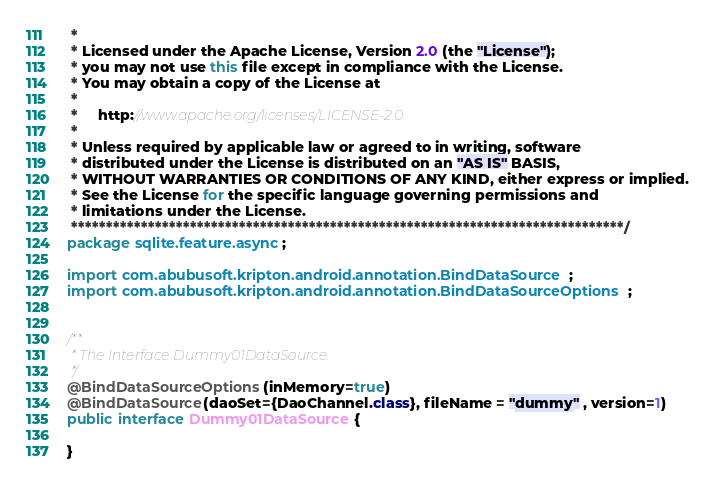Convert code to text. <code><loc_0><loc_0><loc_500><loc_500><_Java_> *
 * Licensed under the Apache License, Version 2.0 (the "License");
 * you may not use this file except in compliance with the License.
 * You may obtain a copy of the License at
 *
 *     http://www.apache.org/licenses/LICENSE-2.0
 *
 * Unless required by applicable law or agreed to in writing, software
 * distributed under the License is distributed on an "AS IS" BASIS,
 * WITHOUT WARRANTIES OR CONDITIONS OF ANY KIND, either express or implied.
 * See the License for the specific language governing permissions and
 * limitations under the License.
 *******************************************************************************/
package sqlite.feature.async;

import com.abubusoft.kripton.android.annotation.BindDataSource;
import com.abubusoft.kripton.android.annotation.BindDataSourceOptions;


/**
 * The Interface Dummy01DataSource.
 */
@BindDataSourceOptions(inMemory=true)
@BindDataSource(daoSet={DaoChannel.class}, fileName = "dummy" , version=1)
public interface Dummy01DataSource {

}
</code> 